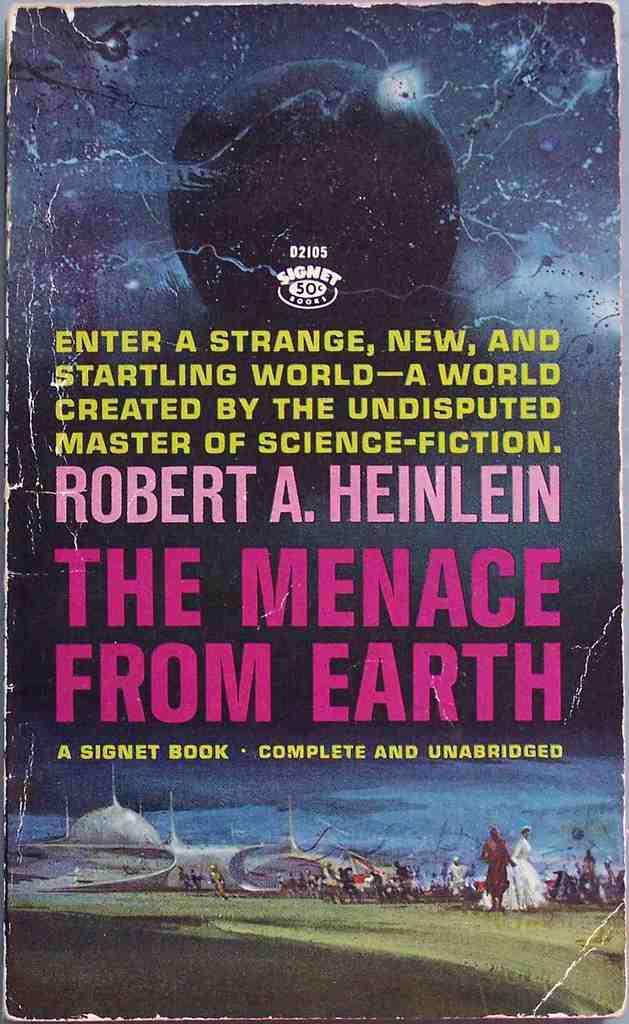Who wrote this book?
Your response must be concise. Robert a. heinlein. 